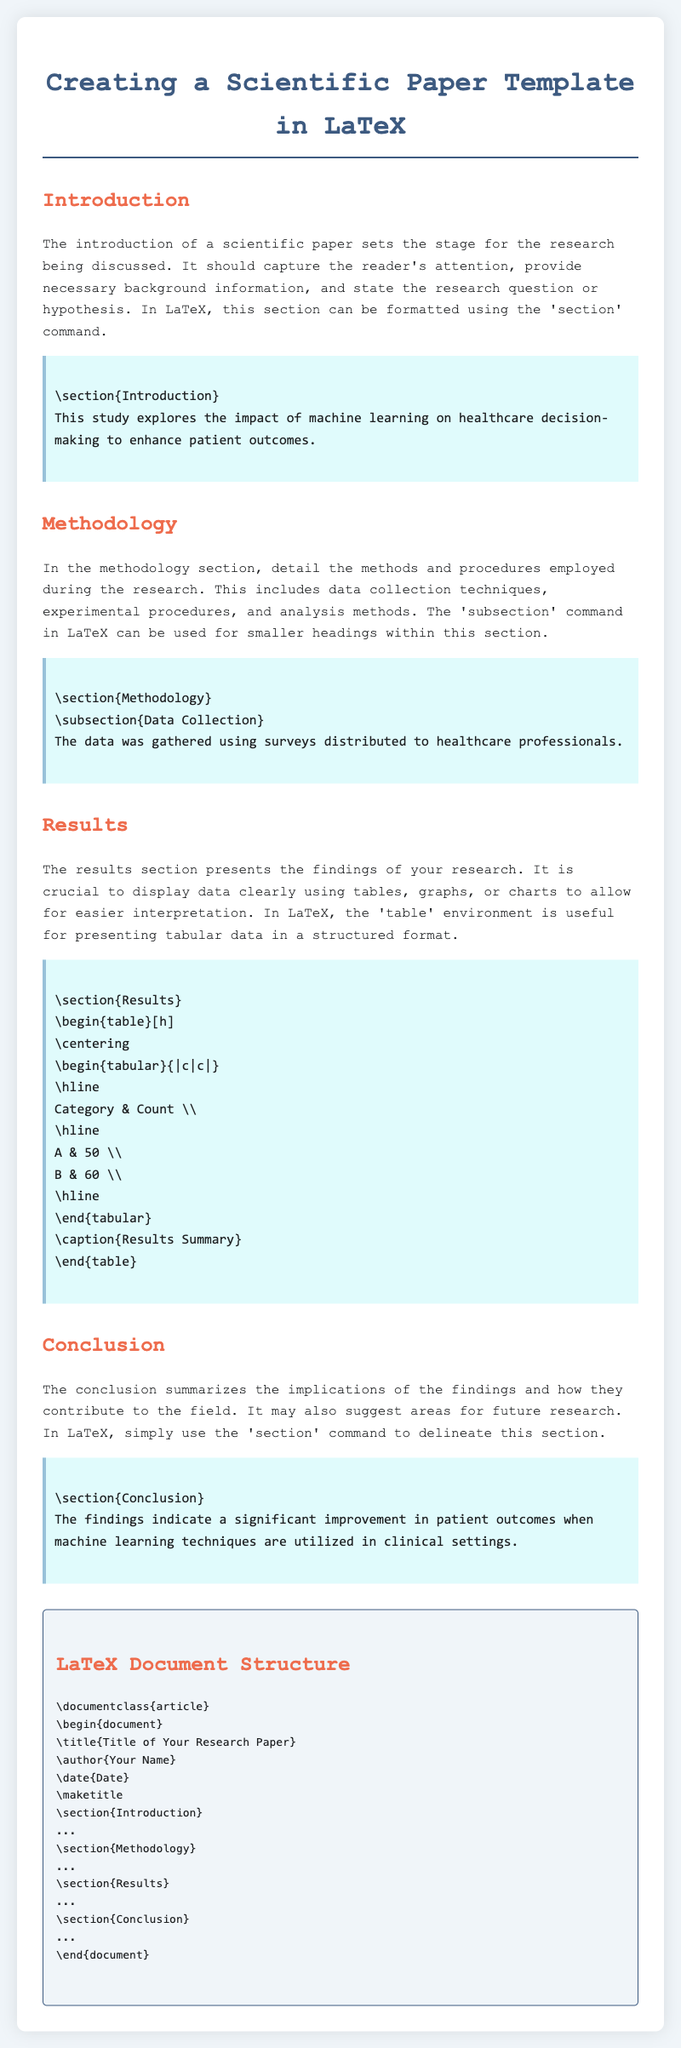what is the title of the document? The title of the document, as indicated in the header, is "Creating a Scientific Paper Template in LaTeX."
Answer: Creating a Scientific Paper Template in LaTeX what section follows the introduction? The order of the sections listed in the document shows that "Methodology" comes after "Introduction."
Answer: Methodology how many subsections are in the methodology section? The methodology section includes one subsection titled "Data Collection."
Answer: one what is the caption of the results table? The table presented in the results section has a caption that summarizes its content.
Answer: Results Summary what font is used for the body text? The document specifies that the "Courier New" font is used for the body text throughout.
Answer: Courier New what is the proposed future research focus in the conclusion? The conclusion section summarizes the implications and suggests exploring future research areas.
Answer: future research what markdown command is used for the methodology section? The LaTeX command employed to denote the methodology section is indicated in the document.
Answer: section what is included in the document structure at the top? The document structure template specifies information that is typically included at the beginning, such as the title and author.
Answer: title, author, date how many categories are displayed in the results table? The results table showcases data categorized under two headings, as observed in the table layout.
Answer: two 